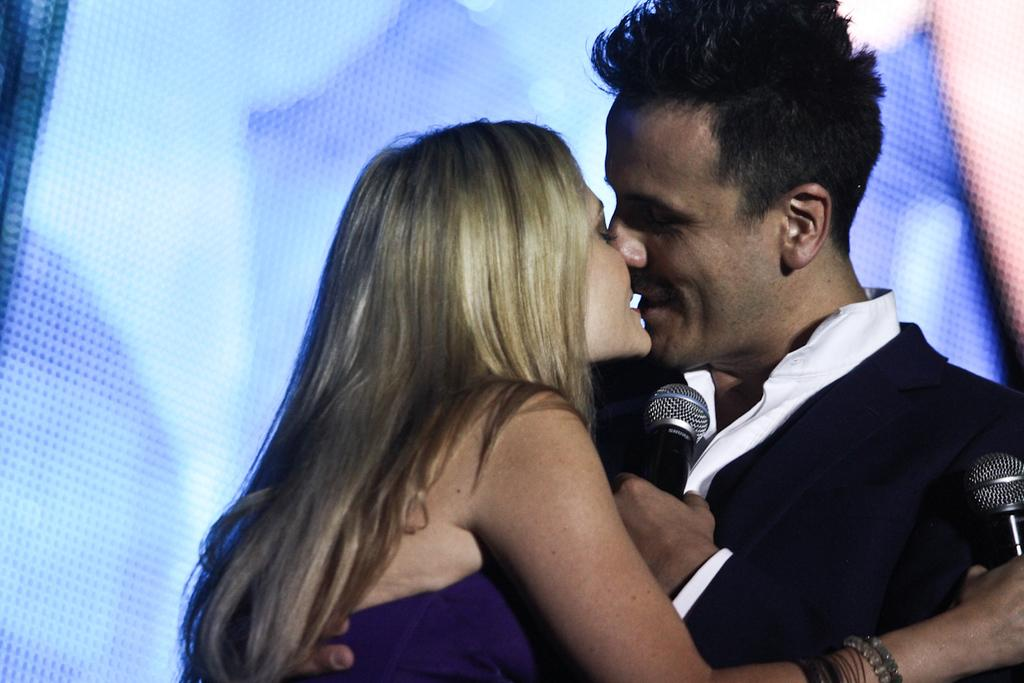What is the man in the image holding? The man is holding a microphone. What is the woman in the image holding? The woman is also holding a microphone. What are the man and woman doing in the image? The man and woman are kissing each other. What type of waste can be seen in the image? There is no waste present in the image. What is the addition to the image that makes it more interesting? The image does not require any additional elements to be interesting, as it already features a man and woman holding microphones and kissing each other. 